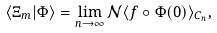Convert formula to latex. <formula><loc_0><loc_0><loc_500><loc_500>\langle \Xi _ { m } | \Phi \rangle = \lim _ { n \to \infty } \mathcal { N } \langle f \circ \Phi ( 0 ) \rangle _ { C _ { n } } ,</formula> 